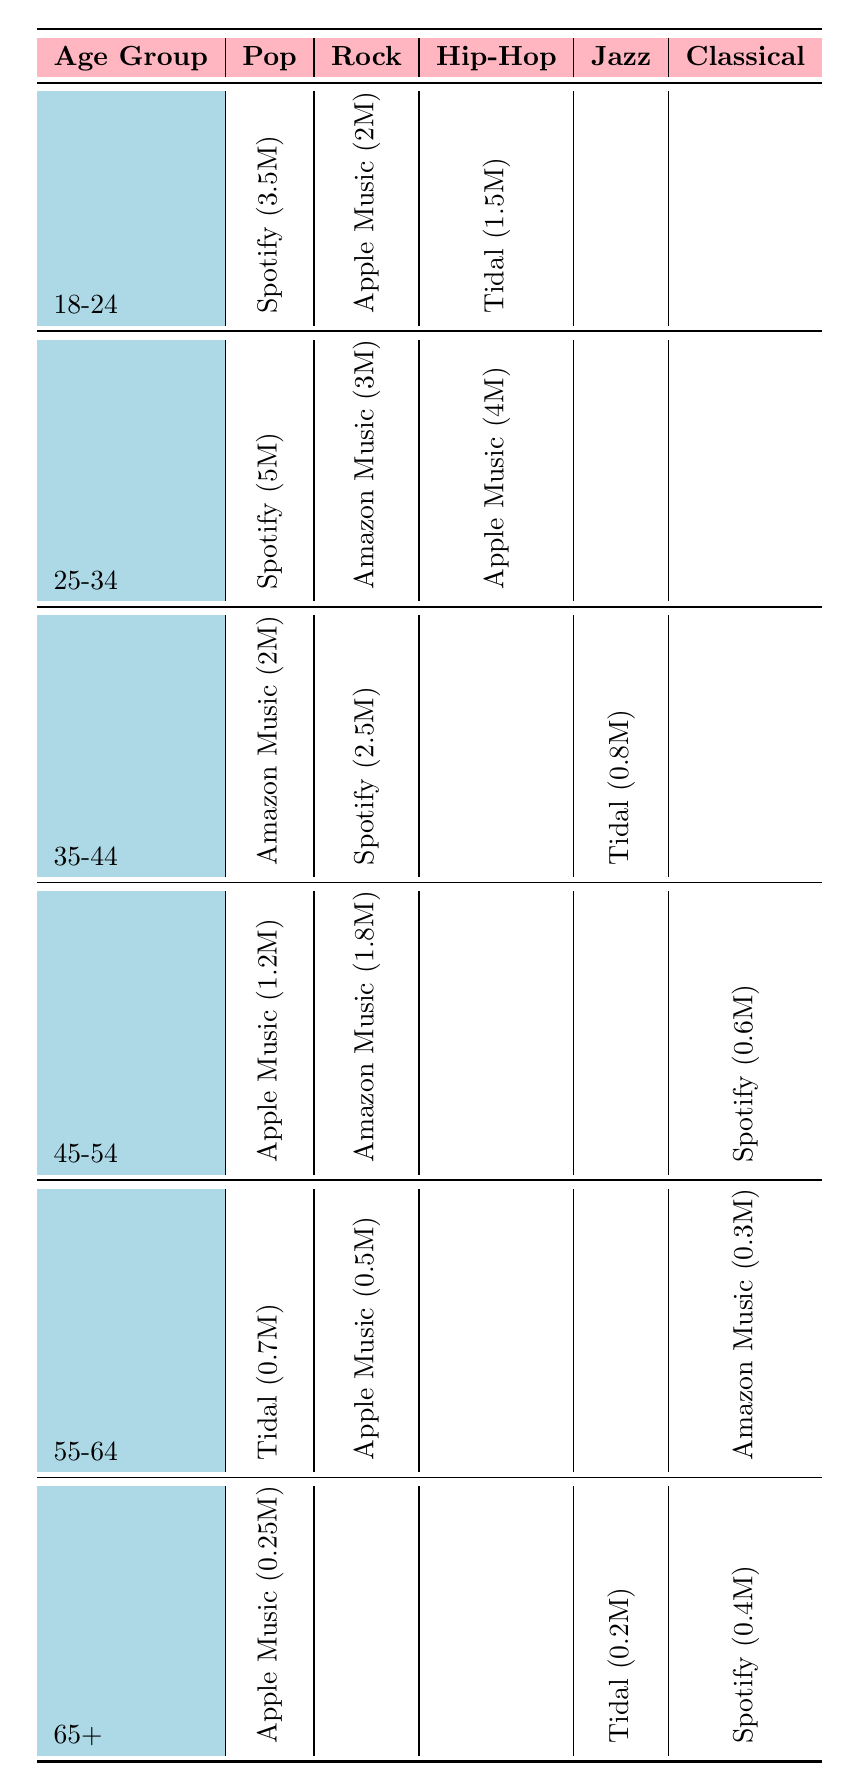What streaming service has the highest subscriptions in the Pop genre for the 25-34 age group? In the 25-34 age group, the Pop genre has Spotify listed with 5 million subscriptions, which is the highest compared to other genres.
Answer: Spotify Which age group has the highest subscription count for the Rock genre? For the Rock genre, the 25-34 age group has Amazon Music with 3 million subscriptions, which is higher than all other age groups.
Answer: 25-34 Is there any age group in the table that has more than 4 million subscriptions for Hip-Hop? The table shows that the maximum subscription for Hip-Hop is 4 million from the 25-34 age group under Apple Music. Therefore, no age group exceeds 4 million.
Answer: No What is the total number of subscriptions for Pop in the 55-64 age group? The Pop genre for the 55-64 age group shows Tidal with 700,000 subscriptions, hence the total is simply this figure.
Answer: 700,000 Which streaming service has the least number of subscriptions in the Classical genre across all age groups? In the Classical genre, the least subscriptions are from Amazon Music with 300,000 in the 55-64 age group.
Answer: Amazon Music If we sum up the subscriptions for Jazz across all age groups, what will the total be? For Jazz, the subscriptions across all age groups are 800,000 (35-44 group) + 200,000 (65+ group), totaling 1,000,000.
Answer: 1,000,000 Is the subscription value for the Rock genre higher in the 45-54 age group compared to the 18-24 age group? For the Rock genre, the 45-54 age group has 1.8 million (Amazon Music) and the 18-24 age group has 2 million (Apple Music), indicating that the 45-54 age group has lower subscriptions.
Answer: No What is the average number of subscriptions for the Hip-Hop genre across all age groups? The only Hip-Hop subscription value is 1.5 million (18-24), 4 million (25-34), and none for the others. The average can be calculated as (1.5M + 4M) / 2 = 2.75 million.
Answer: 2.75 million Which genre holds the highest subscriptions among the 65+ age group? The highest subscriptions in the 65+ age group are in the Classical genre with 400,000 (Spotify), which is greater than the Pop and Jazz genres listed.
Answer: Classical In the 35-44 age group, what percentage of Pop subscriptions are from Amazon Music? In the 35-44 age group, the Pop genre shows 2 million from Amazon Music out of a total of 2 million subscriptions for Pop, resulting in 100%.
Answer: 100% 